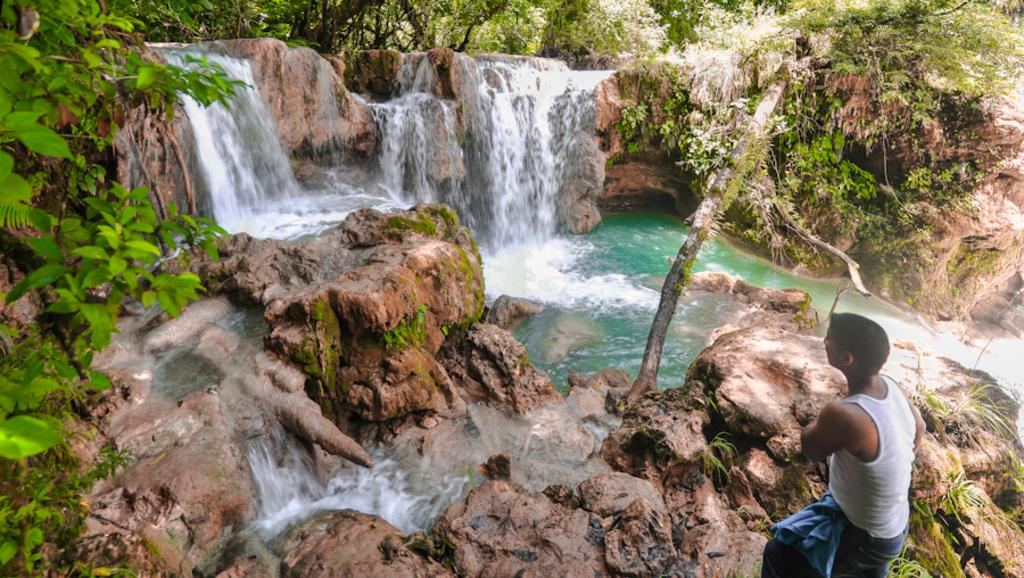What type of natural features can be seen in the image? There are trees and a waterfall in the image. What other types of vegetation are present in the image? There are plants in the image. Where is the person located in the image? The person is standing on a rock surface at the bottom of the image. What type of yam is being harvested by the person in the image? There is no yam present in the image, nor is there any indication that the person is harvesting anything. 